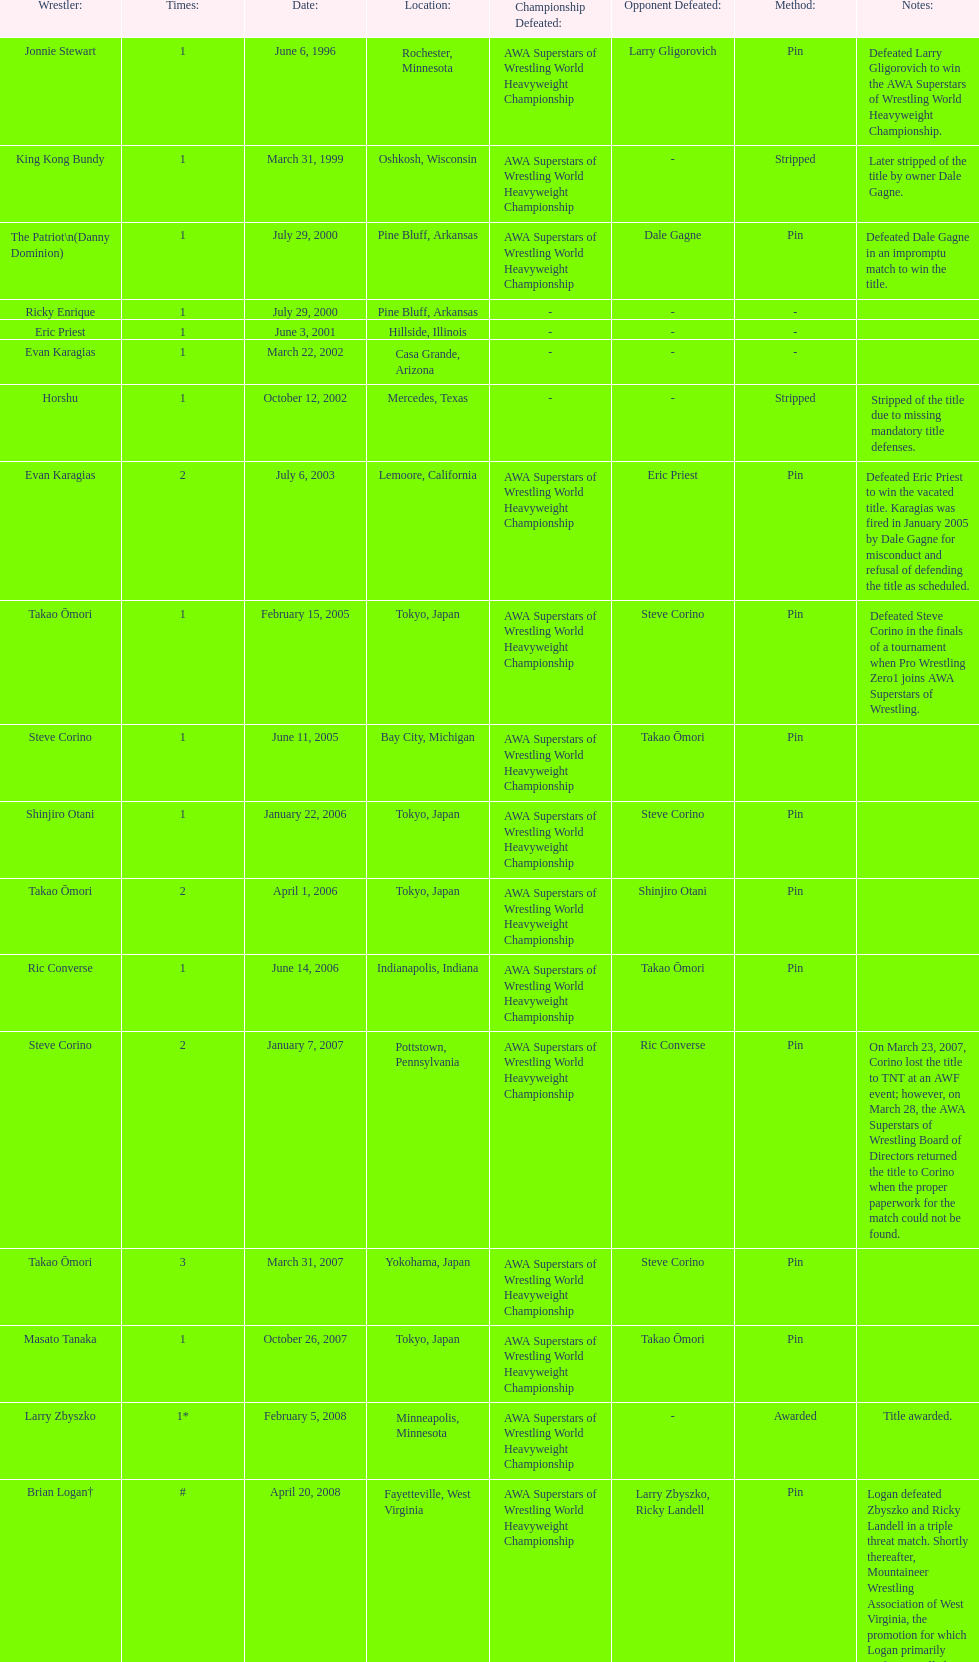Who is the only wsl title holder from texas? Horshu. 